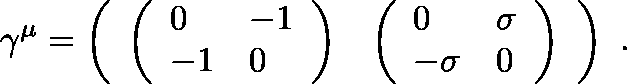Convert formula to latex. <formula><loc_0><loc_0><loc_500><loc_500>\gamma ^ { \mu } = \left ( \begin{array} { l l } { { \left ( \begin{array} { l l } { 0 } & { - 1 } \\ { - 1 } & { 0 } \end{array} \right ) } } & { { \left ( \begin{array} { l l } { 0 } & { \sigma } \\ { - \sigma } & { 0 } \end{array} \right ) } } \end{array} \right ) \ .</formula> 